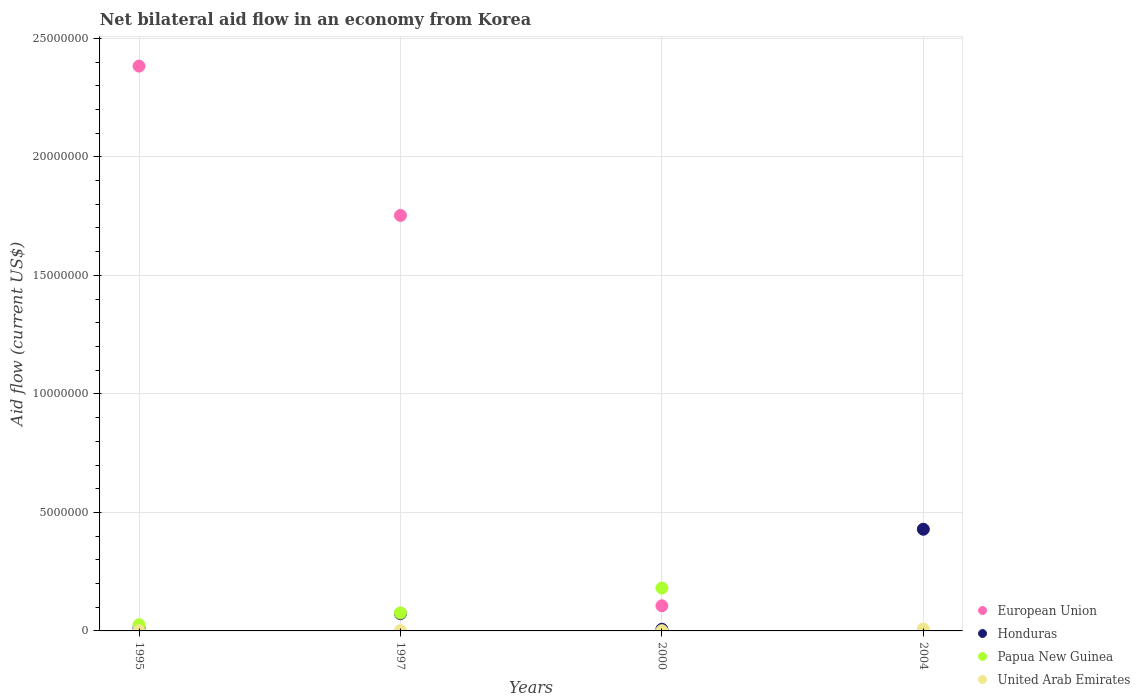How many different coloured dotlines are there?
Make the answer very short. 4. Is the number of dotlines equal to the number of legend labels?
Make the answer very short. No. What is the net bilateral aid flow in European Union in 2004?
Offer a very short reply. 0. Across all years, what is the maximum net bilateral aid flow in Honduras?
Give a very brief answer. 4.29e+06. What is the total net bilateral aid flow in Honduras in the graph?
Your answer should be compact. 5.21e+06. What is the difference between the net bilateral aid flow in United Arab Emirates in 1995 and that in 2000?
Offer a very short reply. 0. What is the difference between the net bilateral aid flow in United Arab Emirates in 2004 and the net bilateral aid flow in Honduras in 1997?
Make the answer very short. -6.50e+05. What is the average net bilateral aid flow in Honduras per year?
Provide a short and direct response. 1.30e+06. In the year 2000, what is the difference between the net bilateral aid flow in European Union and net bilateral aid flow in Honduras?
Offer a terse response. 9.90e+05. In how many years, is the net bilateral aid flow in United Arab Emirates greater than 19000000 US$?
Your answer should be very brief. 0. What is the ratio of the net bilateral aid flow in United Arab Emirates in 1997 to that in 2004?
Give a very brief answer. 0.12. Is the net bilateral aid flow in Honduras in 2000 less than that in 2004?
Make the answer very short. Yes. What is the difference between the highest and the second highest net bilateral aid flow in Honduras?
Keep it short and to the point. 3.56e+06. What is the difference between the highest and the lowest net bilateral aid flow in Papua New Guinea?
Your response must be concise. 1.81e+06. In how many years, is the net bilateral aid flow in European Union greater than the average net bilateral aid flow in European Union taken over all years?
Provide a short and direct response. 2. Is the sum of the net bilateral aid flow in European Union in 1995 and 1997 greater than the maximum net bilateral aid flow in Papua New Guinea across all years?
Provide a succinct answer. Yes. Is it the case that in every year, the sum of the net bilateral aid flow in Papua New Guinea and net bilateral aid flow in European Union  is greater than the net bilateral aid flow in United Arab Emirates?
Provide a short and direct response. No. What is the difference between two consecutive major ticks on the Y-axis?
Your answer should be compact. 5.00e+06. Are the values on the major ticks of Y-axis written in scientific E-notation?
Your response must be concise. No. Does the graph contain any zero values?
Offer a very short reply. Yes. Does the graph contain grids?
Offer a terse response. Yes. Where does the legend appear in the graph?
Provide a succinct answer. Bottom right. How many legend labels are there?
Your response must be concise. 4. How are the legend labels stacked?
Ensure brevity in your answer.  Vertical. What is the title of the graph?
Your answer should be very brief. Net bilateral aid flow in an economy from Korea. Does "Small states" appear as one of the legend labels in the graph?
Offer a terse response. No. What is the label or title of the Y-axis?
Your answer should be very brief. Aid flow (current US$). What is the Aid flow (current US$) in European Union in 1995?
Give a very brief answer. 2.38e+07. What is the Aid flow (current US$) of Honduras in 1995?
Your answer should be very brief. 1.20e+05. What is the Aid flow (current US$) of United Arab Emirates in 1995?
Ensure brevity in your answer.  10000. What is the Aid flow (current US$) of European Union in 1997?
Offer a very short reply. 1.75e+07. What is the Aid flow (current US$) in Honduras in 1997?
Give a very brief answer. 7.30e+05. What is the Aid flow (current US$) of Papua New Guinea in 1997?
Provide a succinct answer. 7.60e+05. What is the Aid flow (current US$) in European Union in 2000?
Give a very brief answer. 1.06e+06. What is the Aid flow (current US$) in Papua New Guinea in 2000?
Keep it short and to the point. 1.81e+06. What is the Aid flow (current US$) of United Arab Emirates in 2000?
Provide a short and direct response. 10000. What is the Aid flow (current US$) in European Union in 2004?
Offer a terse response. 0. What is the Aid flow (current US$) of Honduras in 2004?
Ensure brevity in your answer.  4.29e+06. What is the Aid flow (current US$) in United Arab Emirates in 2004?
Give a very brief answer. 8.00e+04. Across all years, what is the maximum Aid flow (current US$) of European Union?
Offer a terse response. 2.38e+07. Across all years, what is the maximum Aid flow (current US$) of Honduras?
Your response must be concise. 4.29e+06. Across all years, what is the maximum Aid flow (current US$) of Papua New Guinea?
Give a very brief answer. 1.81e+06. Across all years, what is the minimum Aid flow (current US$) in European Union?
Your answer should be very brief. 0. What is the total Aid flow (current US$) in European Union in the graph?
Keep it short and to the point. 4.24e+07. What is the total Aid flow (current US$) of Honduras in the graph?
Give a very brief answer. 5.21e+06. What is the total Aid flow (current US$) of Papua New Guinea in the graph?
Ensure brevity in your answer.  2.83e+06. What is the difference between the Aid flow (current US$) of European Union in 1995 and that in 1997?
Your answer should be compact. 6.30e+06. What is the difference between the Aid flow (current US$) of Honduras in 1995 and that in 1997?
Your answer should be very brief. -6.10e+05. What is the difference between the Aid flow (current US$) of Papua New Guinea in 1995 and that in 1997?
Your answer should be compact. -5.00e+05. What is the difference between the Aid flow (current US$) in European Union in 1995 and that in 2000?
Your answer should be very brief. 2.28e+07. What is the difference between the Aid flow (current US$) of Honduras in 1995 and that in 2000?
Your response must be concise. 5.00e+04. What is the difference between the Aid flow (current US$) of Papua New Guinea in 1995 and that in 2000?
Your answer should be very brief. -1.55e+06. What is the difference between the Aid flow (current US$) of United Arab Emirates in 1995 and that in 2000?
Provide a short and direct response. 0. What is the difference between the Aid flow (current US$) of Honduras in 1995 and that in 2004?
Give a very brief answer. -4.17e+06. What is the difference between the Aid flow (current US$) in United Arab Emirates in 1995 and that in 2004?
Ensure brevity in your answer.  -7.00e+04. What is the difference between the Aid flow (current US$) in European Union in 1997 and that in 2000?
Give a very brief answer. 1.65e+07. What is the difference between the Aid flow (current US$) in Papua New Guinea in 1997 and that in 2000?
Provide a succinct answer. -1.05e+06. What is the difference between the Aid flow (current US$) of Honduras in 1997 and that in 2004?
Give a very brief answer. -3.56e+06. What is the difference between the Aid flow (current US$) in Honduras in 2000 and that in 2004?
Your answer should be compact. -4.22e+06. What is the difference between the Aid flow (current US$) in United Arab Emirates in 2000 and that in 2004?
Your answer should be very brief. -7.00e+04. What is the difference between the Aid flow (current US$) of European Union in 1995 and the Aid flow (current US$) of Honduras in 1997?
Give a very brief answer. 2.31e+07. What is the difference between the Aid flow (current US$) in European Union in 1995 and the Aid flow (current US$) in Papua New Guinea in 1997?
Your answer should be very brief. 2.31e+07. What is the difference between the Aid flow (current US$) of European Union in 1995 and the Aid flow (current US$) of United Arab Emirates in 1997?
Your response must be concise. 2.38e+07. What is the difference between the Aid flow (current US$) of Honduras in 1995 and the Aid flow (current US$) of Papua New Guinea in 1997?
Offer a terse response. -6.40e+05. What is the difference between the Aid flow (current US$) of Honduras in 1995 and the Aid flow (current US$) of United Arab Emirates in 1997?
Ensure brevity in your answer.  1.10e+05. What is the difference between the Aid flow (current US$) in European Union in 1995 and the Aid flow (current US$) in Honduras in 2000?
Your answer should be compact. 2.38e+07. What is the difference between the Aid flow (current US$) of European Union in 1995 and the Aid flow (current US$) of Papua New Guinea in 2000?
Ensure brevity in your answer.  2.20e+07. What is the difference between the Aid flow (current US$) in European Union in 1995 and the Aid flow (current US$) in United Arab Emirates in 2000?
Offer a very short reply. 2.38e+07. What is the difference between the Aid flow (current US$) of Honduras in 1995 and the Aid flow (current US$) of Papua New Guinea in 2000?
Offer a very short reply. -1.69e+06. What is the difference between the Aid flow (current US$) of Honduras in 1995 and the Aid flow (current US$) of United Arab Emirates in 2000?
Make the answer very short. 1.10e+05. What is the difference between the Aid flow (current US$) of Papua New Guinea in 1995 and the Aid flow (current US$) of United Arab Emirates in 2000?
Offer a very short reply. 2.50e+05. What is the difference between the Aid flow (current US$) of European Union in 1995 and the Aid flow (current US$) of Honduras in 2004?
Ensure brevity in your answer.  1.95e+07. What is the difference between the Aid flow (current US$) of European Union in 1995 and the Aid flow (current US$) of United Arab Emirates in 2004?
Your answer should be compact. 2.38e+07. What is the difference between the Aid flow (current US$) of European Union in 1997 and the Aid flow (current US$) of Honduras in 2000?
Offer a very short reply. 1.75e+07. What is the difference between the Aid flow (current US$) in European Union in 1997 and the Aid flow (current US$) in Papua New Guinea in 2000?
Make the answer very short. 1.57e+07. What is the difference between the Aid flow (current US$) in European Union in 1997 and the Aid flow (current US$) in United Arab Emirates in 2000?
Ensure brevity in your answer.  1.75e+07. What is the difference between the Aid flow (current US$) in Honduras in 1997 and the Aid flow (current US$) in Papua New Guinea in 2000?
Offer a very short reply. -1.08e+06. What is the difference between the Aid flow (current US$) in Honduras in 1997 and the Aid flow (current US$) in United Arab Emirates in 2000?
Make the answer very short. 7.20e+05. What is the difference between the Aid flow (current US$) of Papua New Guinea in 1997 and the Aid flow (current US$) of United Arab Emirates in 2000?
Offer a terse response. 7.50e+05. What is the difference between the Aid flow (current US$) in European Union in 1997 and the Aid flow (current US$) in Honduras in 2004?
Ensure brevity in your answer.  1.32e+07. What is the difference between the Aid flow (current US$) of European Union in 1997 and the Aid flow (current US$) of United Arab Emirates in 2004?
Keep it short and to the point. 1.74e+07. What is the difference between the Aid flow (current US$) of Honduras in 1997 and the Aid flow (current US$) of United Arab Emirates in 2004?
Your response must be concise. 6.50e+05. What is the difference between the Aid flow (current US$) of Papua New Guinea in 1997 and the Aid flow (current US$) of United Arab Emirates in 2004?
Give a very brief answer. 6.80e+05. What is the difference between the Aid flow (current US$) of European Union in 2000 and the Aid flow (current US$) of Honduras in 2004?
Offer a very short reply. -3.23e+06. What is the difference between the Aid flow (current US$) of European Union in 2000 and the Aid flow (current US$) of United Arab Emirates in 2004?
Provide a succinct answer. 9.80e+05. What is the difference between the Aid flow (current US$) in Honduras in 2000 and the Aid flow (current US$) in United Arab Emirates in 2004?
Your answer should be very brief. -10000. What is the difference between the Aid flow (current US$) in Papua New Guinea in 2000 and the Aid flow (current US$) in United Arab Emirates in 2004?
Give a very brief answer. 1.73e+06. What is the average Aid flow (current US$) in European Union per year?
Your answer should be very brief. 1.06e+07. What is the average Aid flow (current US$) in Honduras per year?
Give a very brief answer. 1.30e+06. What is the average Aid flow (current US$) in Papua New Guinea per year?
Offer a terse response. 7.08e+05. What is the average Aid flow (current US$) of United Arab Emirates per year?
Provide a succinct answer. 2.75e+04. In the year 1995, what is the difference between the Aid flow (current US$) of European Union and Aid flow (current US$) of Honduras?
Give a very brief answer. 2.37e+07. In the year 1995, what is the difference between the Aid flow (current US$) of European Union and Aid flow (current US$) of Papua New Guinea?
Ensure brevity in your answer.  2.36e+07. In the year 1995, what is the difference between the Aid flow (current US$) of European Union and Aid flow (current US$) of United Arab Emirates?
Make the answer very short. 2.38e+07. In the year 1995, what is the difference between the Aid flow (current US$) in Honduras and Aid flow (current US$) in Papua New Guinea?
Your response must be concise. -1.40e+05. In the year 1995, what is the difference between the Aid flow (current US$) in Papua New Guinea and Aid flow (current US$) in United Arab Emirates?
Provide a succinct answer. 2.50e+05. In the year 1997, what is the difference between the Aid flow (current US$) in European Union and Aid flow (current US$) in Honduras?
Your answer should be compact. 1.68e+07. In the year 1997, what is the difference between the Aid flow (current US$) in European Union and Aid flow (current US$) in Papua New Guinea?
Provide a succinct answer. 1.68e+07. In the year 1997, what is the difference between the Aid flow (current US$) in European Union and Aid flow (current US$) in United Arab Emirates?
Keep it short and to the point. 1.75e+07. In the year 1997, what is the difference between the Aid flow (current US$) of Honduras and Aid flow (current US$) of Papua New Guinea?
Offer a terse response. -3.00e+04. In the year 1997, what is the difference between the Aid flow (current US$) in Honduras and Aid flow (current US$) in United Arab Emirates?
Ensure brevity in your answer.  7.20e+05. In the year 1997, what is the difference between the Aid flow (current US$) in Papua New Guinea and Aid flow (current US$) in United Arab Emirates?
Your response must be concise. 7.50e+05. In the year 2000, what is the difference between the Aid flow (current US$) of European Union and Aid flow (current US$) of Honduras?
Give a very brief answer. 9.90e+05. In the year 2000, what is the difference between the Aid flow (current US$) in European Union and Aid flow (current US$) in Papua New Guinea?
Your answer should be very brief. -7.50e+05. In the year 2000, what is the difference between the Aid flow (current US$) in European Union and Aid flow (current US$) in United Arab Emirates?
Offer a terse response. 1.05e+06. In the year 2000, what is the difference between the Aid flow (current US$) of Honduras and Aid flow (current US$) of Papua New Guinea?
Offer a terse response. -1.74e+06. In the year 2000, what is the difference between the Aid flow (current US$) of Honduras and Aid flow (current US$) of United Arab Emirates?
Make the answer very short. 6.00e+04. In the year 2000, what is the difference between the Aid flow (current US$) in Papua New Guinea and Aid flow (current US$) in United Arab Emirates?
Ensure brevity in your answer.  1.80e+06. In the year 2004, what is the difference between the Aid flow (current US$) of Honduras and Aid flow (current US$) of United Arab Emirates?
Ensure brevity in your answer.  4.21e+06. What is the ratio of the Aid flow (current US$) of European Union in 1995 to that in 1997?
Provide a succinct answer. 1.36. What is the ratio of the Aid flow (current US$) in Honduras in 1995 to that in 1997?
Keep it short and to the point. 0.16. What is the ratio of the Aid flow (current US$) of Papua New Guinea in 1995 to that in 1997?
Your answer should be very brief. 0.34. What is the ratio of the Aid flow (current US$) of United Arab Emirates in 1995 to that in 1997?
Make the answer very short. 1. What is the ratio of the Aid flow (current US$) of European Union in 1995 to that in 2000?
Give a very brief answer. 22.48. What is the ratio of the Aid flow (current US$) in Honduras in 1995 to that in 2000?
Keep it short and to the point. 1.71. What is the ratio of the Aid flow (current US$) of Papua New Guinea in 1995 to that in 2000?
Give a very brief answer. 0.14. What is the ratio of the Aid flow (current US$) of United Arab Emirates in 1995 to that in 2000?
Ensure brevity in your answer.  1. What is the ratio of the Aid flow (current US$) of Honduras in 1995 to that in 2004?
Offer a very short reply. 0.03. What is the ratio of the Aid flow (current US$) in European Union in 1997 to that in 2000?
Offer a terse response. 16.54. What is the ratio of the Aid flow (current US$) in Honduras in 1997 to that in 2000?
Keep it short and to the point. 10.43. What is the ratio of the Aid flow (current US$) in Papua New Guinea in 1997 to that in 2000?
Keep it short and to the point. 0.42. What is the ratio of the Aid flow (current US$) of Honduras in 1997 to that in 2004?
Give a very brief answer. 0.17. What is the ratio of the Aid flow (current US$) of United Arab Emirates in 1997 to that in 2004?
Provide a short and direct response. 0.12. What is the ratio of the Aid flow (current US$) in Honduras in 2000 to that in 2004?
Offer a terse response. 0.02. What is the difference between the highest and the second highest Aid flow (current US$) of European Union?
Your answer should be compact. 6.30e+06. What is the difference between the highest and the second highest Aid flow (current US$) of Honduras?
Provide a succinct answer. 3.56e+06. What is the difference between the highest and the second highest Aid flow (current US$) of Papua New Guinea?
Ensure brevity in your answer.  1.05e+06. What is the difference between the highest and the lowest Aid flow (current US$) in European Union?
Your answer should be compact. 2.38e+07. What is the difference between the highest and the lowest Aid flow (current US$) of Honduras?
Give a very brief answer. 4.22e+06. What is the difference between the highest and the lowest Aid flow (current US$) of Papua New Guinea?
Offer a very short reply. 1.81e+06. What is the difference between the highest and the lowest Aid flow (current US$) of United Arab Emirates?
Provide a short and direct response. 7.00e+04. 